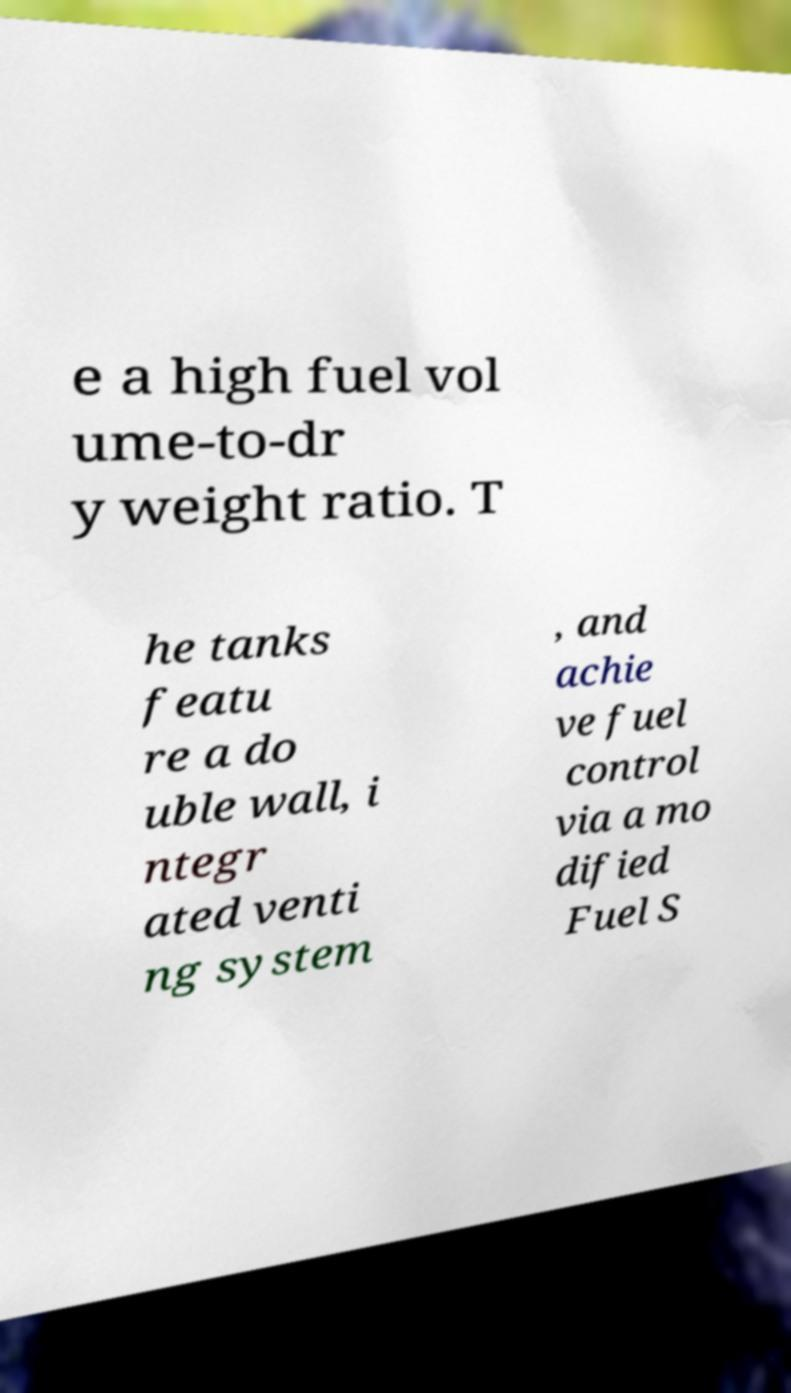Can you accurately transcribe the text from the provided image for me? e a high fuel vol ume-to-dr y weight ratio. T he tanks featu re a do uble wall, i ntegr ated venti ng system , and achie ve fuel control via a mo dified Fuel S 